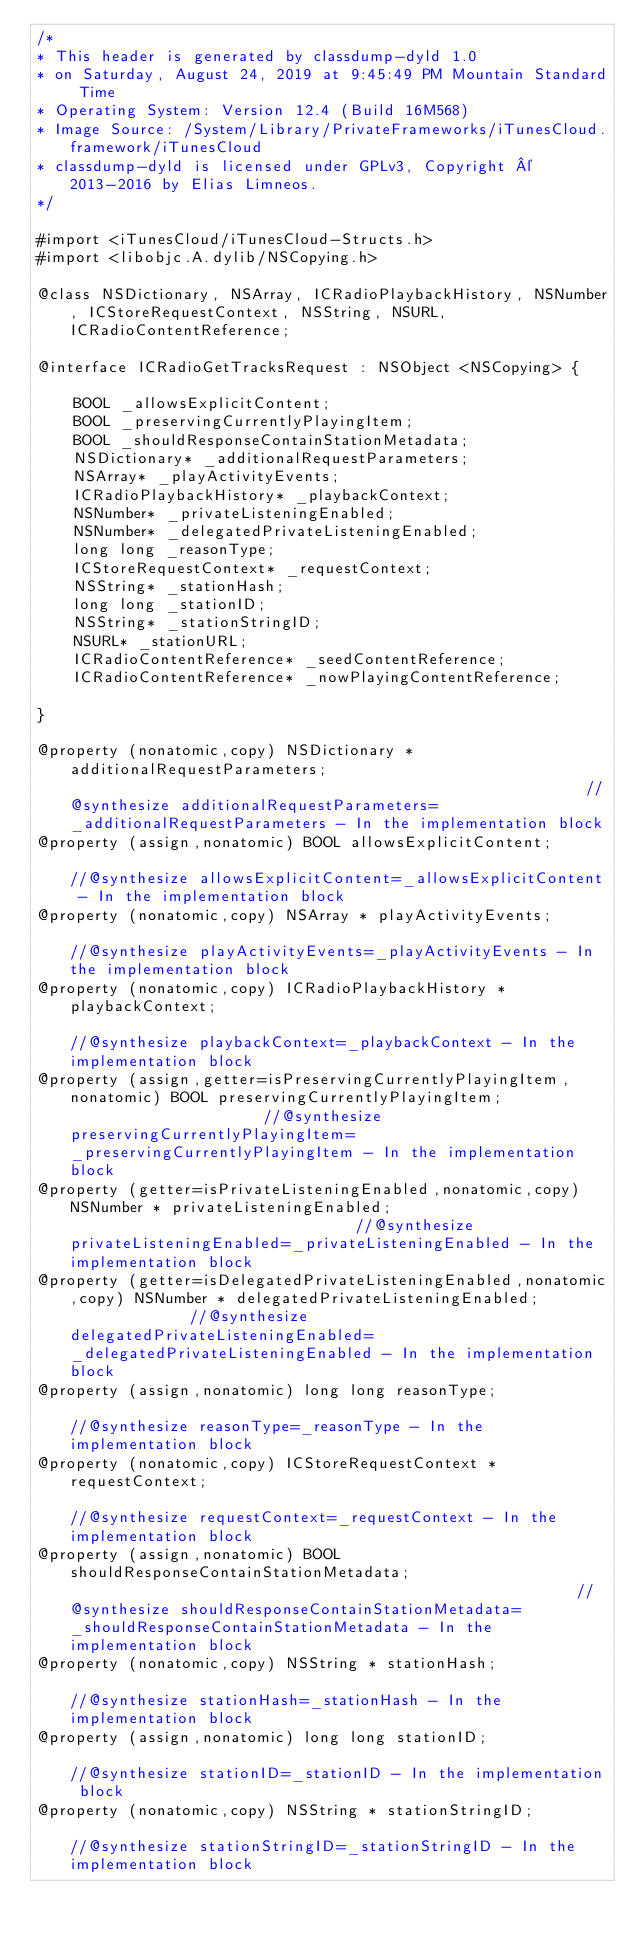<code> <loc_0><loc_0><loc_500><loc_500><_C_>/*
* This header is generated by classdump-dyld 1.0
* on Saturday, August 24, 2019 at 9:45:49 PM Mountain Standard Time
* Operating System: Version 12.4 (Build 16M568)
* Image Source: /System/Library/PrivateFrameworks/iTunesCloud.framework/iTunesCloud
* classdump-dyld is licensed under GPLv3, Copyright © 2013-2016 by Elias Limneos.
*/

#import <iTunesCloud/iTunesCloud-Structs.h>
#import <libobjc.A.dylib/NSCopying.h>

@class NSDictionary, NSArray, ICRadioPlaybackHistory, NSNumber, ICStoreRequestContext, NSString, NSURL, ICRadioContentReference;

@interface ICRadioGetTracksRequest : NSObject <NSCopying> {

	BOOL _allowsExplicitContent;
	BOOL _preservingCurrentlyPlayingItem;
	BOOL _shouldResponseContainStationMetadata;
	NSDictionary* _additionalRequestParameters;
	NSArray* _playActivityEvents;
	ICRadioPlaybackHistory* _playbackContext;
	NSNumber* _privateListeningEnabled;
	NSNumber* _delegatedPrivateListeningEnabled;
	long long _reasonType;
	ICStoreRequestContext* _requestContext;
	NSString* _stationHash;
	long long _stationID;
	NSString* _stationStringID;
	NSURL* _stationURL;
	ICRadioContentReference* _seedContentReference;
	ICRadioContentReference* _nowPlayingContentReference;

}

@property (nonatomic,copy) NSDictionary * additionalRequestParameters;                                                         //@synthesize additionalRequestParameters=_additionalRequestParameters - In the implementation block
@property (assign,nonatomic) BOOL allowsExplicitContent;                                                                       //@synthesize allowsExplicitContent=_allowsExplicitContent - In the implementation block
@property (nonatomic,copy) NSArray * playActivityEvents;                                                                       //@synthesize playActivityEvents=_playActivityEvents - In the implementation block
@property (nonatomic,copy) ICRadioPlaybackHistory * playbackContext;                                                           //@synthesize playbackContext=_playbackContext - In the implementation block
@property (assign,getter=isPreservingCurrentlyPlayingItem,nonatomic) BOOL preservingCurrentlyPlayingItem;                      //@synthesize preservingCurrentlyPlayingItem=_preservingCurrentlyPlayingItem - In the implementation block
@property (getter=isPrivateListeningEnabled,nonatomic,copy) NSNumber * privateListeningEnabled;                                //@synthesize privateListeningEnabled=_privateListeningEnabled - In the implementation block
@property (getter=isDelegatedPrivateListeningEnabled,nonatomic,copy) NSNumber * delegatedPrivateListeningEnabled;              //@synthesize delegatedPrivateListeningEnabled=_delegatedPrivateListeningEnabled - In the implementation block
@property (assign,nonatomic) long long reasonType;                                                                             //@synthesize reasonType=_reasonType - In the implementation block
@property (nonatomic,copy) ICStoreRequestContext * requestContext;                                                             //@synthesize requestContext=_requestContext - In the implementation block
@property (assign,nonatomic) BOOL shouldResponseContainStationMetadata;                                                        //@synthesize shouldResponseContainStationMetadata=_shouldResponseContainStationMetadata - In the implementation block
@property (nonatomic,copy) NSString * stationHash;                                                                             //@synthesize stationHash=_stationHash - In the implementation block
@property (assign,nonatomic) long long stationID;                                                                              //@synthesize stationID=_stationID - In the implementation block
@property (nonatomic,copy) NSString * stationStringID;                                                                         //@synthesize stationStringID=_stationStringID - In the implementation block</code> 